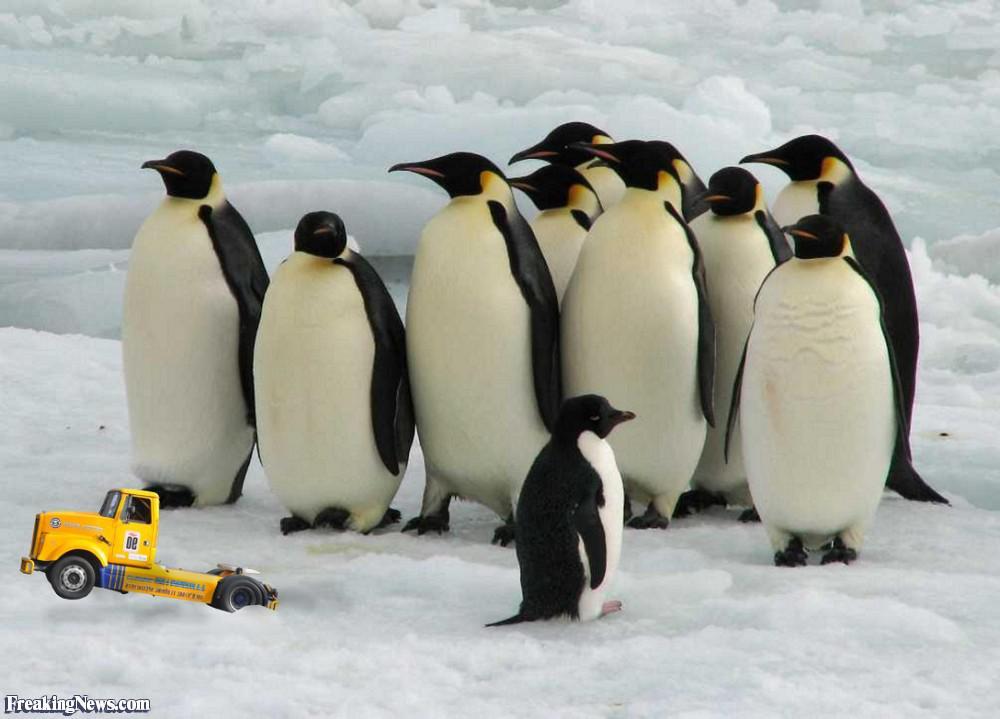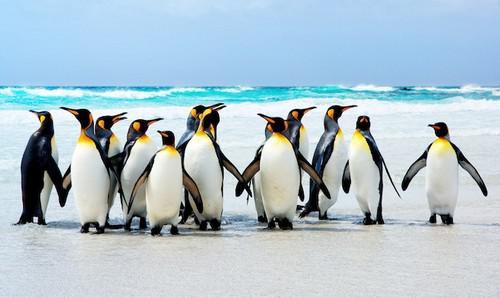The first image is the image on the left, the second image is the image on the right. Evaluate the accuracy of this statement regarding the images: "One of the images depicts exactly three penguins.". Is it true? Answer yes or no. No. 